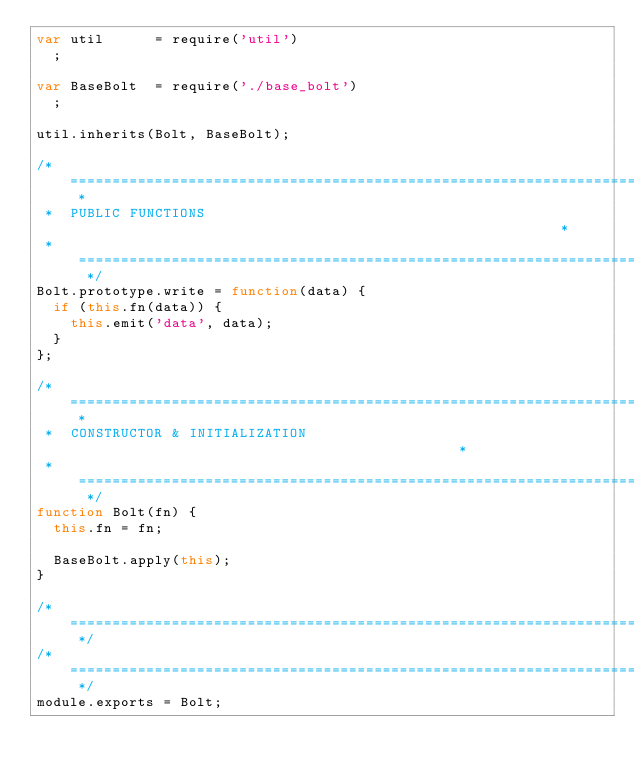Convert code to text. <code><loc_0><loc_0><loc_500><loc_500><_JavaScript_>var util      = require('util')
  ;

var BaseBolt  = require('./base_bolt')
  ;

util.inherits(Bolt, BaseBolt);

/* ========================================================================== *
 *  PUBLIC FUNCTIONS                                                          *
 * ========================================================================== */
Bolt.prototype.write = function(data) {
  if (this.fn(data)) {
    this.emit('data', data);
  }
};

/* ========================================================================== *
 *  CONSTRUCTOR & INITIALIZATION                                              *
 * ========================================================================== */
function Bolt(fn) {
  this.fn = fn;

  BaseBolt.apply(this);
}

/* ========================================================================== */
/* ========================================================================== */
module.exports = Bolt;
</code> 